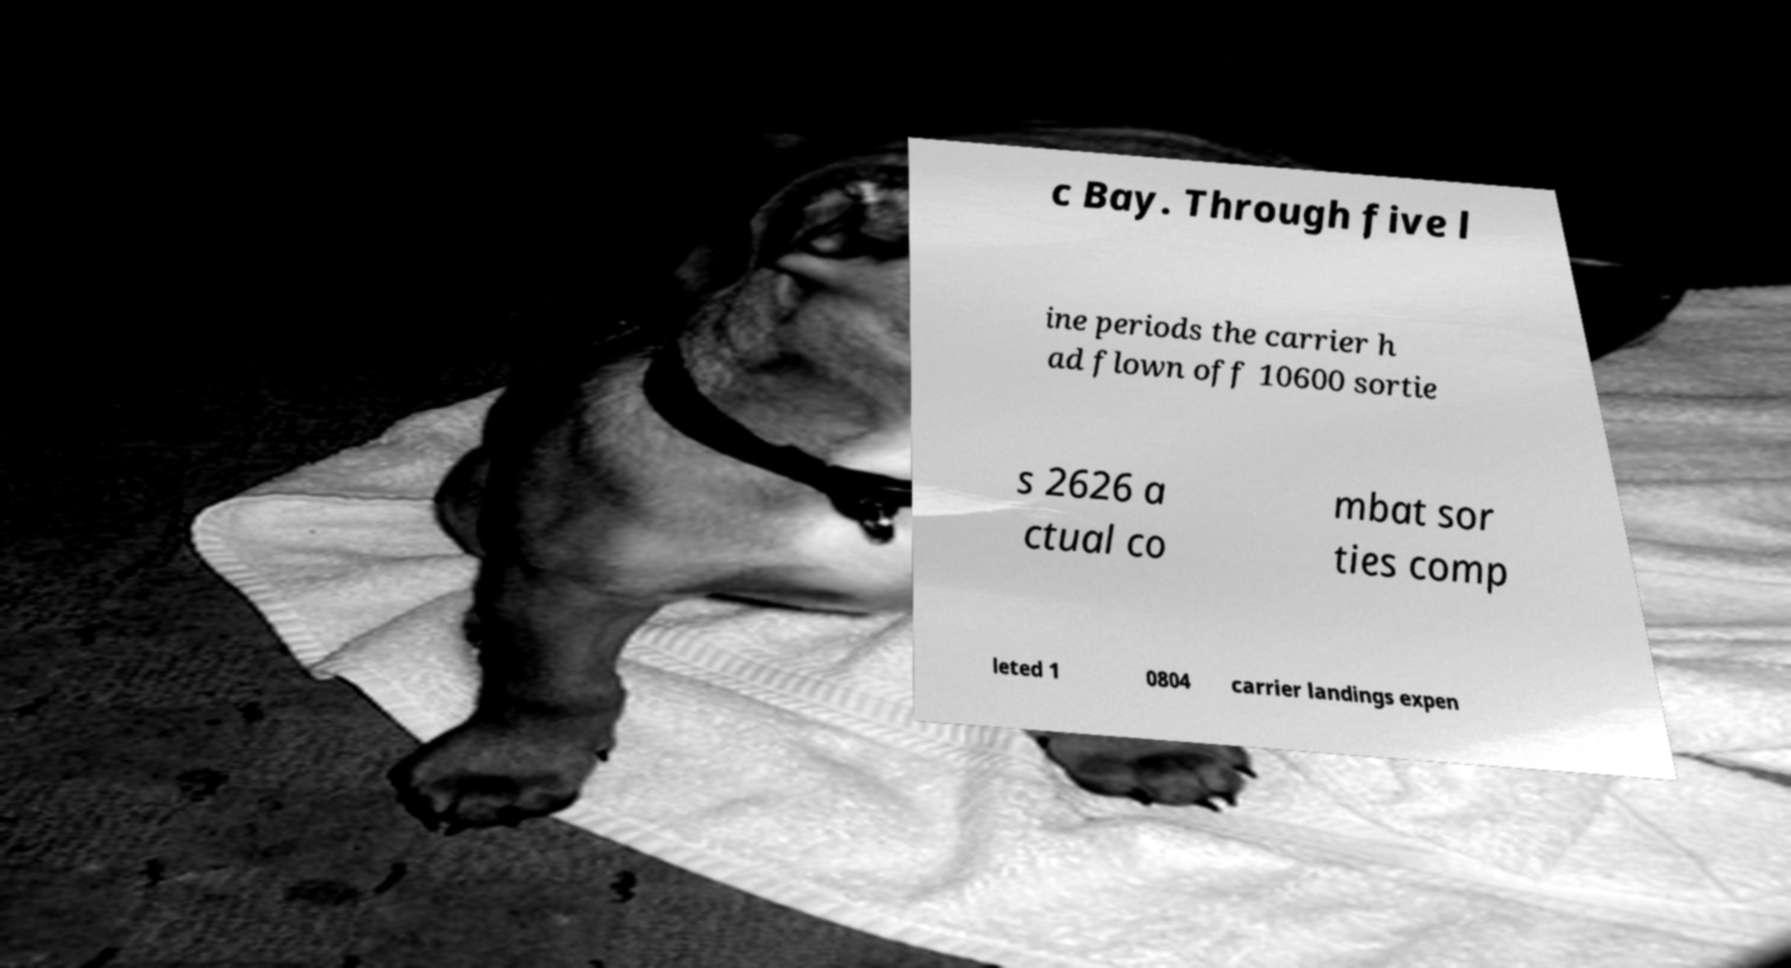For documentation purposes, I need the text within this image transcribed. Could you provide that? c Bay. Through five l ine periods the carrier h ad flown off 10600 sortie s 2626 a ctual co mbat sor ties comp leted 1 0804 carrier landings expen 